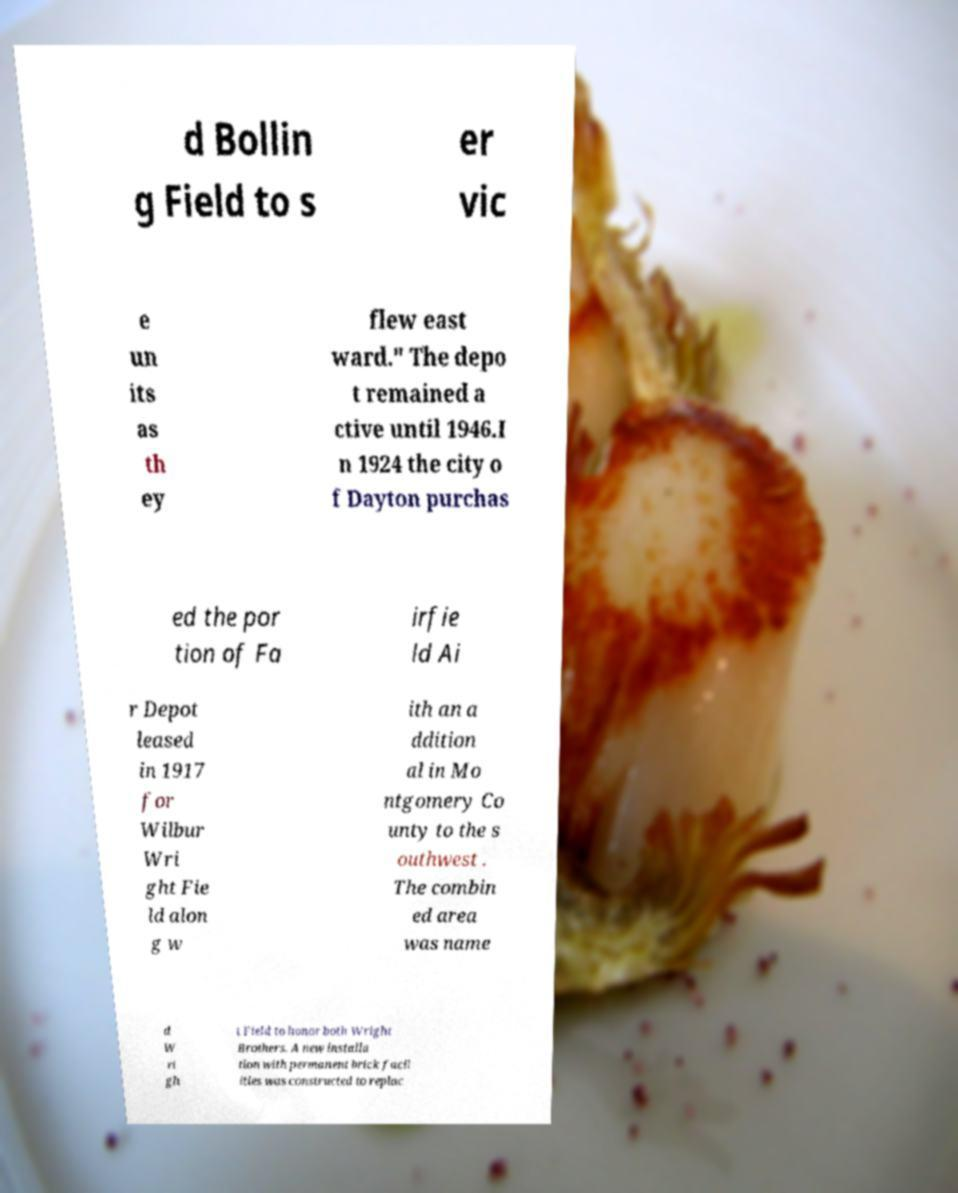Could you assist in decoding the text presented in this image and type it out clearly? d Bollin g Field to s er vic e un its as th ey flew east ward." The depo t remained a ctive until 1946.I n 1924 the city o f Dayton purchas ed the por tion of Fa irfie ld Ai r Depot leased in 1917 for Wilbur Wri ght Fie ld alon g w ith an a ddition al in Mo ntgomery Co unty to the s outhwest . The combin ed area was name d W ri gh t Field to honor both Wright Brothers. A new installa tion with permanent brick facil ities was constructed to replac 